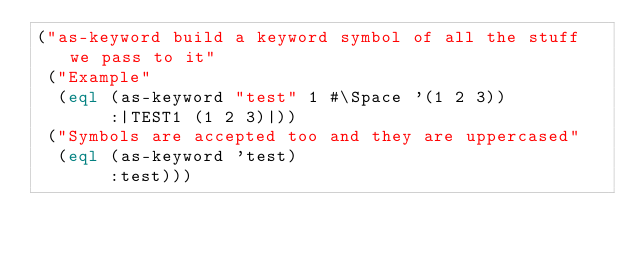Convert code to text. <code><loc_0><loc_0><loc_500><loc_500><_Lisp_>("as-keyword build a keyword symbol of all the stuff we pass to it"
 ("Example"
  (eql (as-keyword "test" 1 #\Space '(1 2 3))
       :|TEST1 (1 2 3)|))
 ("Symbols are accepted too and they are uppercased"
  (eql (as-keyword 'test)
       :test)))</code> 